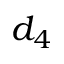Convert formula to latex. <formula><loc_0><loc_0><loc_500><loc_500>d _ { 4 }</formula> 